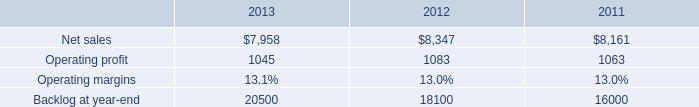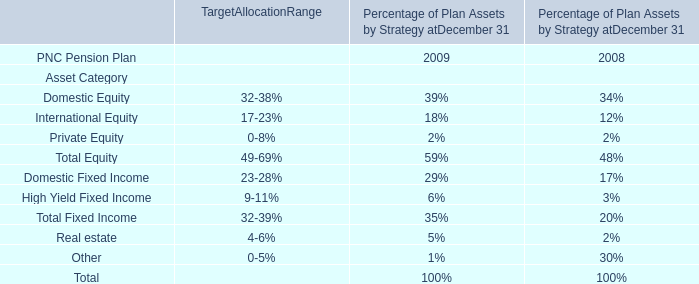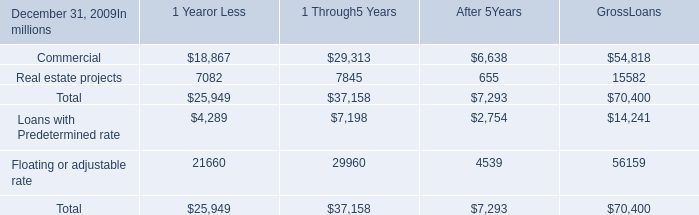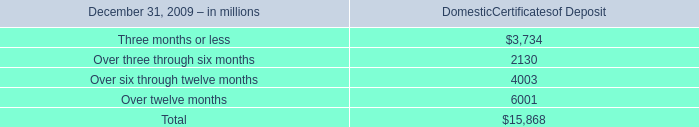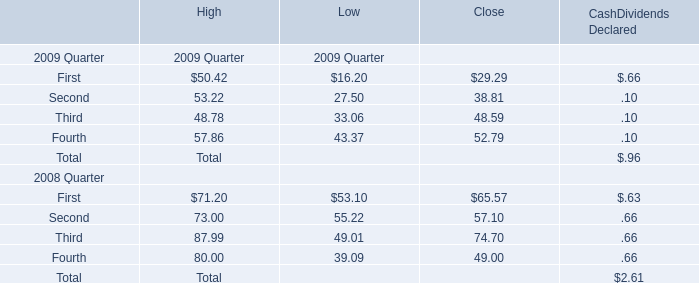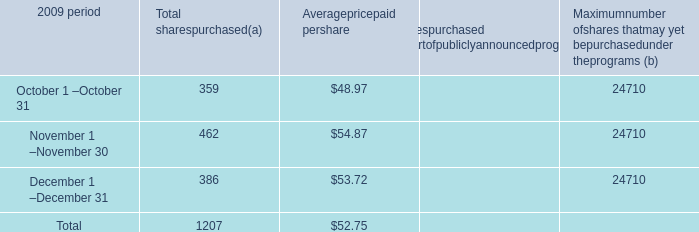What's the 20 % of total Domestic Certificates of Deposit in 2009? 
Computations: (15868 * 0.2)
Answer: 3173.6. 